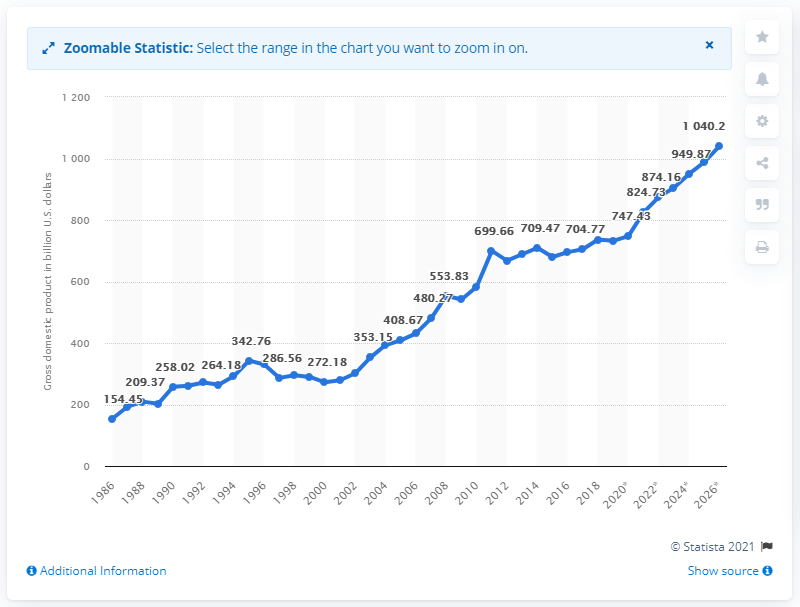Give some essential details in this illustration. In 2019, the Gross Domestic Product (GDP) of Switzerland was 732.19. 